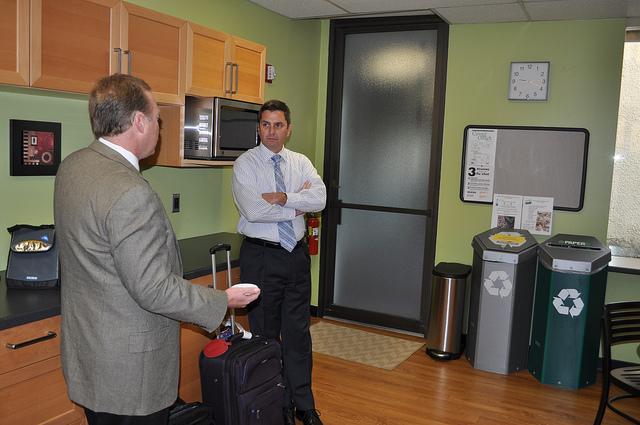How many men are there?
Concise answer only. 2. What color is the man's tie?
Answer briefly. Blue. What color is the backsplash?
Be succinct. Green. Does the man have on dress pants?
Quick response, please. Yes. How many recycle bins are there?
Concise answer only. 2. What is behind the person?
Quick response, please. Microwave. 